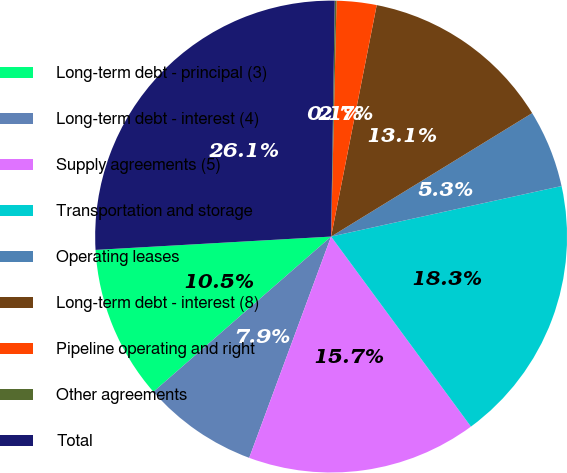<chart> <loc_0><loc_0><loc_500><loc_500><pie_chart><fcel>Long-term debt - principal (3)<fcel>Long-term debt - interest (4)<fcel>Supply agreements (5)<fcel>Transportation and storage<fcel>Operating leases<fcel>Long-term debt - interest (8)<fcel>Pipeline operating and right<fcel>Other agreements<fcel>Total<nl><fcel>10.53%<fcel>7.93%<fcel>15.74%<fcel>18.34%<fcel>5.33%<fcel>13.14%<fcel>2.73%<fcel>0.12%<fcel>26.15%<nl></chart> 